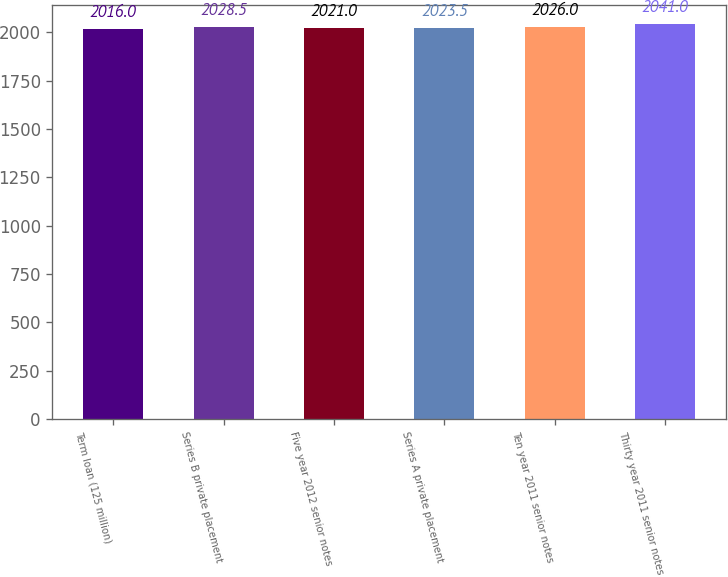Convert chart. <chart><loc_0><loc_0><loc_500><loc_500><bar_chart><fcel>Term loan (125 million)<fcel>Series B private placement<fcel>Five year 2012 senior notes<fcel>Series A private placement<fcel>Ten year 2011 senior notes<fcel>Thirty year 2011 senior notes<nl><fcel>2016<fcel>2028.5<fcel>2021<fcel>2023.5<fcel>2026<fcel>2041<nl></chart> 